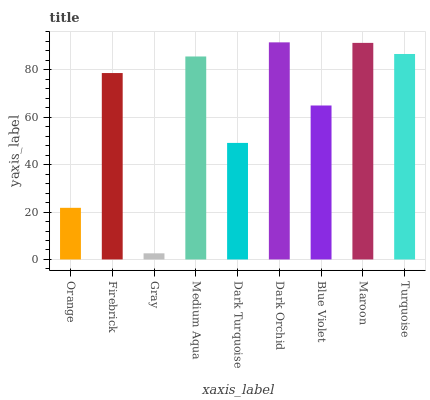Is Firebrick the minimum?
Answer yes or no. No. Is Firebrick the maximum?
Answer yes or no. No. Is Firebrick greater than Orange?
Answer yes or no. Yes. Is Orange less than Firebrick?
Answer yes or no. Yes. Is Orange greater than Firebrick?
Answer yes or no. No. Is Firebrick less than Orange?
Answer yes or no. No. Is Firebrick the high median?
Answer yes or no. Yes. Is Firebrick the low median?
Answer yes or no. Yes. Is Dark Turquoise the high median?
Answer yes or no. No. Is Dark Orchid the low median?
Answer yes or no. No. 